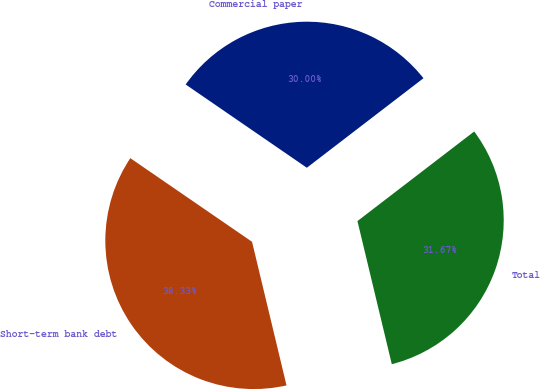<chart> <loc_0><loc_0><loc_500><loc_500><pie_chart><fcel>Commercial paper<fcel>Short-term bank debt<fcel>Total<nl><fcel>30.0%<fcel>38.33%<fcel>31.67%<nl></chart> 